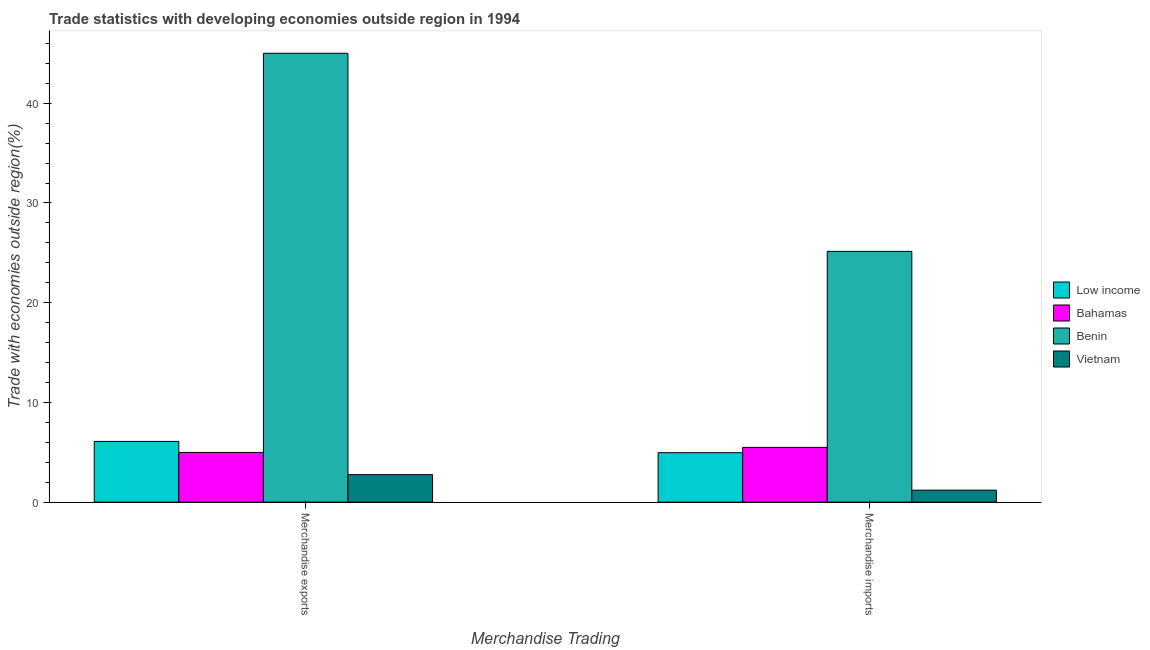How many groups of bars are there?
Offer a very short reply. 2. How many bars are there on the 1st tick from the left?
Provide a succinct answer. 4. How many bars are there on the 1st tick from the right?
Provide a succinct answer. 4. What is the label of the 1st group of bars from the left?
Offer a very short reply. Merchandise exports. What is the merchandise imports in Low income?
Make the answer very short. 4.96. Across all countries, what is the maximum merchandise exports?
Ensure brevity in your answer.  45.01. Across all countries, what is the minimum merchandise imports?
Make the answer very short. 1.2. In which country was the merchandise exports maximum?
Offer a very short reply. Benin. In which country was the merchandise exports minimum?
Keep it short and to the point. Vietnam. What is the total merchandise exports in the graph?
Offer a terse response. 58.84. What is the difference between the merchandise imports in Bahamas and that in Vietnam?
Ensure brevity in your answer.  4.29. What is the difference between the merchandise exports in Bahamas and the merchandise imports in Benin?
Give a very brief answer. -20.16. What is the average merchandise exports per country?
Provide a succinct answer. 14.71. What is the difference between the merchandise imports and merchandise exports in Bahamas?
Your answer should be very brief. 0.51. What is the ratio of the merchandise imports in Benin to that in Bahamas?
Provide a short and direct response. 4.58. Is the merchandise imports in Low income less than that in Bahamas?
Give a very brief answer. Yes. What does the 3rd bar from the left in Merchandise imports represents?
Offer a very short reply. Benin. What does the 2nd bar from the right in Merchandise exports represents?
Your response must be concise. Benin. How many countries are there in the graph?
Offer a very short reply. 4. What is the difference between two consecutive major ticks on the Y-axis?
Keep it short and to the point. 10. Are the values on the major ticks of Y-axis written in scientific E-notation?
Offer a terse response. No. Does the graph contain any zero values?
Provide a succinct answer. No. Does the graph contain grids?
Provide a short and direct response. No. What is the title of the graph?
Your response must be concise. Trade statistics with developing economies outside region in 1994. Does "Canada" appear as one of the legend labels in the graph?
Give a very brief answer. No. What is the label or title of the X-axis?
Give a very brief answer. Merchandise Trading. What is the label or title of the Y-axis?
Your response must be concise. Trade with economies outside region(%). What is the Trade with economies outside region(%) in Low income in Merchandise exports?
Your answer should be compact. 6.09. What is the Trade with economies outside region(%) of Bahamas in Merchandise exports?
Provide a short and direct response. 4.98. What is the Trade with economies outside region(%) of Benin in Merchandise exports?
Your answer should be very brief. 45.01. What is the Trade with economies outside region(%) of Vietnam in Merchandise exports?
Ensure brevity in your answer.  2.76. What is the Trade with economies outside region(%) of Low income in Merchandise imports?
Give a very brief answer. 4.96. What is the Trade with economies outside region(%) of Bahamas in Merchandise imports?
Provide a short and direct response. 5.49. What is the Trade with economies outside region(%) in Benin in Merchandise imports?
Keep it short and to the point. 25.15. What is the Trade with economies outside region(%) of Vietnam in Merchandise imports?
Your answer should be compact. 1.2. Across all Merchandise Trading, what is the maximum Trade with economies outside region(%) in Low income?
Your answer should be very brief. 6.09. Across all Merchandise Trading, what is the maximum Trade with economies outside region(%) in Bahamas?
Offer a terse response. 5.49. Across all Merchandise Trading, what is the maximum Trade with economies outside region(%) in Benin?
Give a very brief answer. 45.01. Across all Merchandise Trading, what is the maximum Trade with economies outside region(%) in Vietnam?
Offer a very short reply. 2.76. Across all Merchandise Trading, what is the minimum Trade with economies outside region(%) in Low income?
Your response must be concise. 4.96. Across all Merchandise Trading, what is the minimum Trade with economies outside region(%) of Bahamas?
Give a very brief answer. 4.98. Across all Merchandise Trading, what is the minimum Trade with economies outside region(%) in Benin?
Give a very brief answer. 25.15. Across all Merchandise Trading, what is the minimum Trade with economies outside region(%) of Vietnam?
Keep it short and to the point. 1.2. What is the total Trade with economies outside region(%) in Low income in the graph?
Your answer should be very brief. 11.05. What is the total Trade with economies outside region(%) in Bahamas in the graph?
Your answer should be very brief. 10.47. What is the total Trade with economies outside region(%) of Benin in the graph?
Keep it short and to the point. 70.16. What is the total Trade with economies outside region(%) of Vietnam in the graph?
Provide a short and direct response. 3.96. What is the difference between the Trade with economies outside region(%) of Low income in Merchandise exports and that in Merchandise imports?
Offer a terse response. 1.13. What is the difference between the Trade with economies outside region(%) of Bahamas in Merchandise exports and that in Merchandise imports?
Provide a succinct answer. -0.51. What is the difference between the Trade with economies outside region(%) in Benin in Merchandise exports and that in Merchandise imports?
Give a very brief answer. 19.87. What is the difference between the Trade with economies outside region(%) of Vietnam in Merchandise exports and that in Merchandise imports?
Your response must be concise. 1.56. What is the difference between the Trade with economies outside region(%) of Low income in Merchandise exports and the Trade with economies outside region(%) of Bahamas in Merchandise imports?
Your answer should be compact. 0.6. What is the difference between the Trade with economies outside region(%) of Low income in Merchandise exports and the Trade with economies outside region(%) of Benin in Merchandise imports?
Your answer should be compact. -19.06. What is the difference between the Trade with economies outside region(%) of Low income in Merchandise exports and the Trade with economies outside region(%) of Vietnam in Merchandise imports?
Keep it short and to the point. 4.89. What is the difference between the Trade with economies outside region(%) in Bahamas in Merchandise exports and the Trade with economies outside region(%) in Benin in Merchandise imports?
Offer a terse response. -20.16. What is the difference between the Trade with economies outside region(%) of Bahamas in Merchandise exports and the Trade with economies outside region(%) of Vietnam in Merchandise imports?
Provide a succinct answer. 3.78. What is the difference between the Trade with economies outside region(%) in Benin in Merchandise exports and the Trade with economies outside region(%) in Vietnam in Merchandise imports?
Keep it short and to the point. 43.81. What is the average Trade with economies outside region(%) in Low income per Merchandise Trading?
Provide a succinct answer. 5.52. What is the average Trade with economies outside region(%) of Bahamas per Merchandise Trading?
Offer a terse response. 5.24. What is the average Trade with economies outside region(%) in Benin per Merchandise Trading?
Your answer should be very brief. 35.08. What is the average Trade with economies outside region(%) of Vietnam per Merchandise Trading?
Offer a terse response. 1.98. What is the difference between the Trade with economies outside region(%) of Low income and Trade with economies outside region(%) of Bahamas in Merchandise exports?
Your answer should be very brief. 1.11. What is the difference between the Trade with economies outside region(%) in Low income and Trade with economies outside region(%) in Benin in Merchandise exports?
Your answer should be compact. -38.92. What is the difference between the Trade with economies outside region(%) in Low income and Trade with economies outside region(%) in Vietnam in Merchandise exports?
Give a very brief answer. 3.33. What is the difference between the Trade with economies outside region(%) of Bahamas and Trade with economies outside region(%) of Benin in Merchandise exports?
Your response must be concise. -40.03. What is the difference between the Trade with economies outside region(%) in Bahamas and Trade with economies outside region(%) in Vietnam in Merchandise exports?
Offer a terse response. 2.23. What is the difference between the Trade with economies outside region(%) in Benin and Trade with economies outside region(%) in Vietnam in Merchandise exports?
Make the answer very short. 42.26. What is the difference between the Trade with economies outside region(%) in Low income and Trade with economies outside region(%) in Bahamas in Merchandise imports?
Your response must be concise. -0.53. What is the difference between the Trade with economies outside region(%) of Low income and Trade with economies outside region(%) of Benin in Merchandise imports?
Make the answer very short. -20.19. What is the difference between the Trade with economies outside region(%) of Low income and Trade with economies outside region(%) of Vietnam in Merchandise imports?
Your answer should be very brief. 3.76. What is the difference between the Trade with economies outside region(%) in Bahamas and Trade with economies outside region(%) in Benin in Merchandise imports?
Offer a very short reply. -19.66. What is the difference between the Trade with economies outside region(%) of Bahamas and Trade with economies outside region(%) of Vietnam in Merchandise imports?
Keep it short and to the point. 4.29. What is the difference between the Trade with economies outside region(%) of Benin and Trade with economies outside region(%) of Vietnam in Merchandise imports?
Your answer should be compact. 23.95. What is the ratio of the Trade with economies outside region(%) in Low income in Merchandise exports to that in Merchandise imports?
Offer a terse response. 1.23. What is the ratio of the Trade with economies outside region(%) of Bahamas in Merchandise exports to that in Merchandise imports?
Make the answer very short. 0.91. What is the ratio of the Trade with economies outside region(%) in Benin in Merchandise exports to that in Merchandise imports?
Offer a terse response. 1.79. What is the ratio of the Trade with economies outside region(%) in Vietnam in Merchandise exports to that in Merchandise imports?
Give a very brief answer. 2.3. What is the difference between the highest and the second highest Trade with economies outside region(%) in Low income?
Make the answer very short. 1.13. What is the difference between the highest and the second highest Trade with economies outside region(%) in Bahamas?
Provide a short and direct response. 0.51. What is the difference between the highest and the second highest Trade with economies outside region(%) of Benin?
Provide a short and direct response. 19.87. What is the difference between the highest and the second highest Trade with economies outside region(%) in Vietnam?
Offer a very short reply. 1.56. What is the difference between the highest and the lowest Trade with economies outside region(%) of Low income?
Ensure brevity in your answer.  1.13. What is the difference between the highest and the lowest Trade with economies outside region(%) of Bahamas?
Your response must be concise. 0.51. What is the difference between the highest and the lowest Trade with economies outside region(%) of Benin?
Provide a short and direct response. 19.87. What is the difference between the highest and the lowest Trade with economies outside region(%) of Vietnam?
Your answer should be very brief. 1.56. 